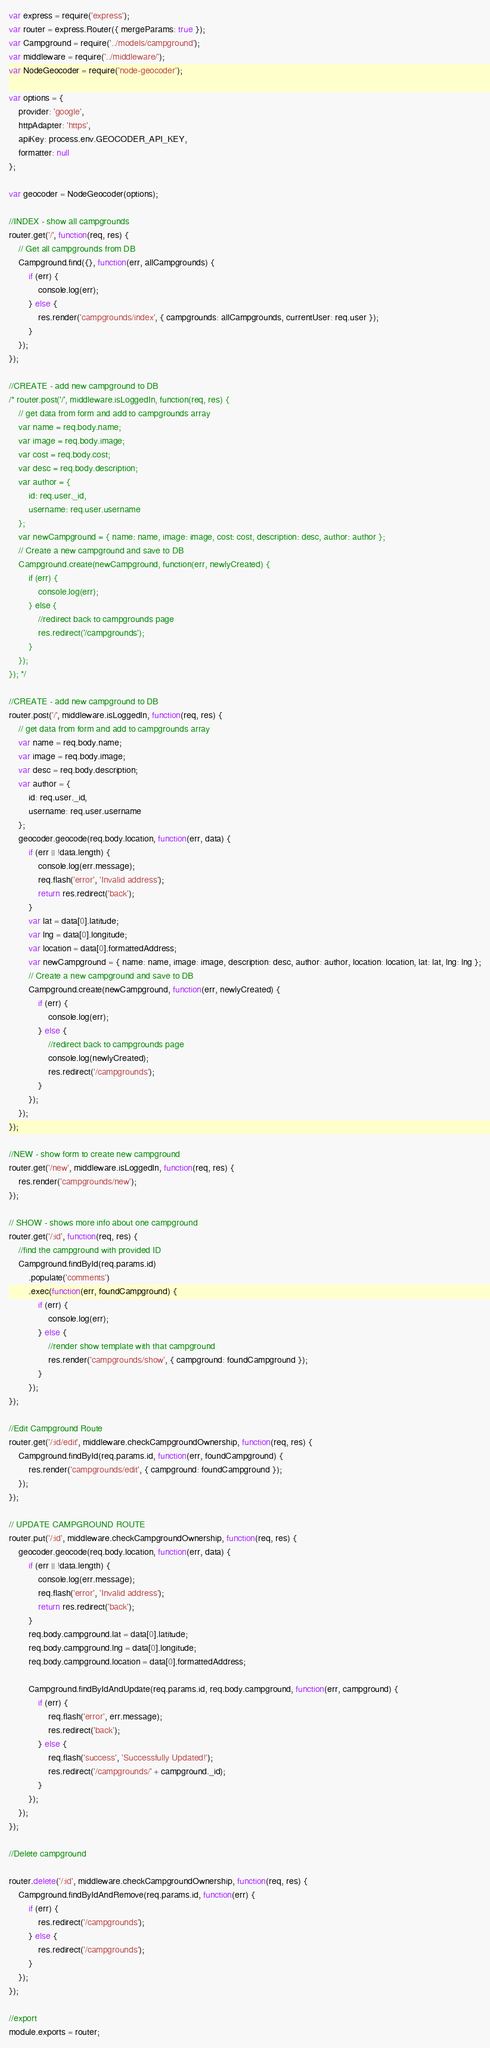<code> <loc_0><loc_0><loc_500><loc_500><_JavaScript_>var express = require('express');
var router = express.Router({ mergeParams: true });
var Campground = require('../models/campground');
var middleware = require('../middleware/');
var NodeGeocoder = require('node-geocoder');

var options = {
	provider: 'google',
	httpAdapter: 'https',
	apiKey: process.env.GEOCODER_API_KEY,
	formatter: null
};

var geocoder = NodeGeocoder(options);

//INDEX - show all campgrounds
router.get('/', function(req, res) {
	// Get all campgrounds from DB
	Campground.find({}, function(err, allCampgrounds) {
		if (err) {
			console.log(err);
		} else {
			res.render('campgrounds/index', { campgrounds: allCampgrounds, currentUser: req.user });
		}
	});
});

//CREATE - add new campground to DB
/* router.post('/', middleware.isLoggedIn, function(req, res) {
	// get data from form and add to campgrounds array
	var name = req.body.name;
	var image = req.body.image;
	var cost = req.body.cost;
	var desc = req.body.description;
	var author = {
		id: req.user._id,
		username: req.user.username
	};
	var newCampground = { name: name, image: image, cost: cost, description: desc, author: author };
	// Create a new campground and save to DB
	Campground.create(newCampground, function(err, newlyCreated) {
		if (err) {
			console.log(err);
		} else {
			//redirect back to campgrounds page
			res.redirect('/campgrounds');
		}
	});
}); */

//CREATE - add new campground to DB
router.post('/', middleware.isLoggedIn, function(req, res) {
	// get data from form and add to campgrounds array
	var name = req.body.name;
	var image = req.body.image;
	var desc = req.body.description;
	var author = {
		id: req.user._id,
		username: req.user.username
	};
	geocoder.geocode(req.body.location, function(err, data) {
		if (err || !data.length) {
			console.log(err.message);
			req.flash('error', 'Invalid address');
			return res.redirect('back');
		}
		var lat = data[0].latitude;
		var lng = data[0].longitude;
		var location = data[0].formattedAddress;
		var newCampground = { name: name, image: image, description: desc, author: author, location: location, lat: lat, lng: lng };
		// Create a new campground and save to DB
		Campground.create(newCampground, function(err, newlyCreated) {
			if (err) {
				console.log(err);
			} else {
				//redirect back to campgrounds page
				console.log(newlyCreated);
				res.redirect('/campgrounds');
			}
		});
	});
});

//NEW - show form to create new campground
router.get('/new', middleware.isLoggedIn, function(req, res) {
	res.render('campgrounds/new');
});

// SHOW - shows more info about one campground
router.get('/:id', function(req, res) {
	//find the campground with provided ID
	Campground.findById(req.params.id)
		.populate('comments')
		.exec(function(err, foundCampground) {
			if (err) {
				console.log(err);
			} else {
				//render show template with that campground
				res.render('campgrounds/show', { campground: foundCampground });
			}
		});
});

//Edit Campground Route
router.get('/:id/edit', middleware.checkCampgroundOwnership, function(req, res) {
	Campground.findById(req.params.id, function(err, foundCampground) {
		res.render('campgrounds/edit', { campground: foundCampground });
	});
});

// UPDATE CAMPGROUND ROUTE
router.put('/:id', middleware.checkCampgroundOwnership, function(req, res) {
	geocoder.geocode(req.body.location, function(err, data) {
		if (err || !data.length) {
			console.log(err.message);
			req.flash('error', 'Invalid address');
			return res.redirect('back');
		}
		req.body.campground.lat = data[0].latitude;
		req.body.campground.lng = data[0].longitude;
		req.body.campground.location = data[0].formattedAddress;

		Campground.findByIdAndUpdate(req.params.id, req.body.campground, function(err, campground) {
			if (err) {
				req.flash('error', err.message);
				res.redirect('back');
			} else {
				req.flash('success', 'Successfully Updated!');
				res.redirect('/campgrounds/' + campground._id);
			}
		});
	});
});

//Delete campground

router.delete('/:id', middleware.checkCampgroundOwnership, function(req, res) {
	Campground.findByIdAndRemove(req.params.id, function(err) {
		if (err) {
			res.redirect('/campgrounds');
		} else {
			res.redirect('/campgrounds');
		}
	});
});

//export
module.exports = router;
</code> 